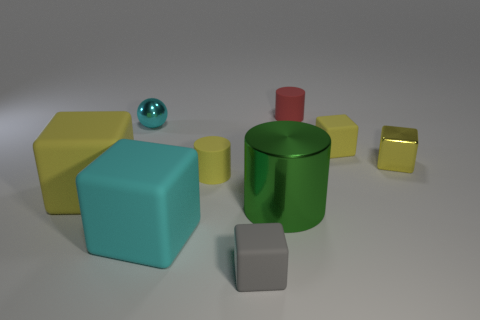Subtract all yellow blocks. How many were subtracted if there are1yellow blocks left? 2 Subtract all metallic cylinders. How many cylinders are left? 2 Subtract all yellow cubes. How many cubes are left? 2 Subtract all spheres. How many objects are left? 8 Subtract 2 cylinders. How many cylinders are left? 1 Subtract all blue cylinders. Subtract all blue blocks. How many cylinders are left? 3 Subtract all green cylinders. How many gray blocks are left? 1 Subtract all large metal cylinders. Subtract all balls. How many objects are left? 7 Add 6 large yellow objects. How many large yellow objects are left? 7 Add 5 tiny yellow rubber cylinders. How many tiny yellow rubber cylinders exist? 6 